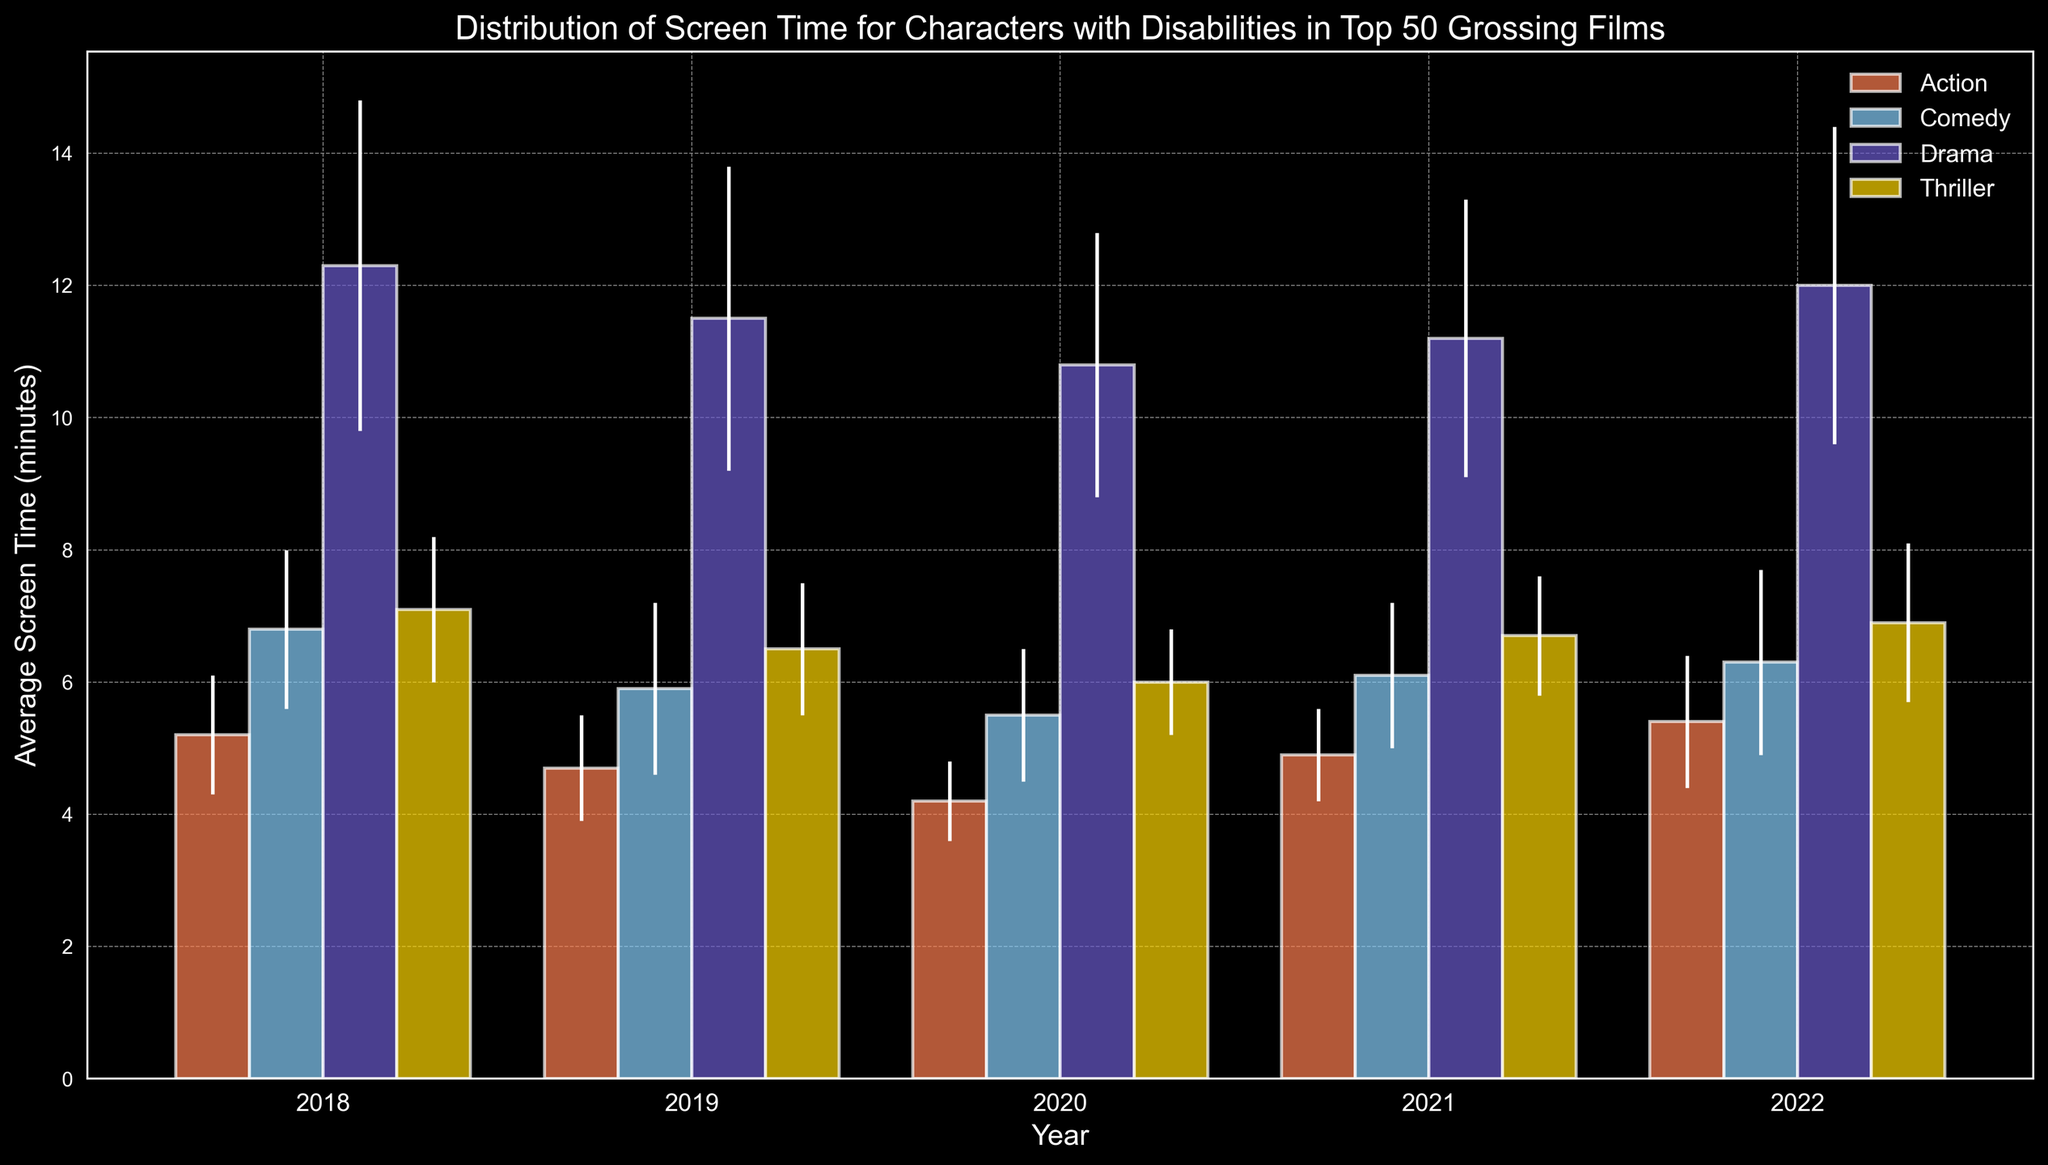What year had the lowest average screen time for characters with disabilities in Action films? Compare the average screen times for Action films across all the years. The lowest average screen time is in 2020 with 4.2 minutes.
Answer: 2020 Which genre showed the most consistent screen time for characters with disabilities from 2018 to 2022? Consistency can be inferred from the smallest standard deviations across the years. Thriller genre consistently has lower standard deviations compared to other genres.
Answer: Thriller Which year saw the highest average screen time for characters with disabilities in Drama films? Compare the average screen times for Drama films across all the years. The highest is in 2018 with 12.3 minutes.
Answer: 2018 Between 2018 and 2022, which genre saw the greatest increase in average screen time for characters with disabilities? Calculate the difference in average screen time for each genre from 2018 to 2022. Drama saw the smallest decrease from 12.3 to 12.0 minutes, while Action saw an increase from 5.2 to 5.4 minutes.
Answer: Action What is the combined average screen time for characters with disabilities in Comedy and Drama films in 2020? Sum the average screen times for Comedy and Drama films in 2020: 5.5 (Comedy) + 10.8 (Drama) = 16.3 minutes.
Answer: 16.3 minutes In which year did Thriller films have nearly the same average screen time as Action films? Compare the average screen times for Thriller and Action films across all the years to find the ones that are close. In 2021, Thriller had 6.7 minutes, and Action had 4.9 minutes.
Answer: 2021 Are the average screen times for characters with disabilities in Comedy films higher or lower than those in Action films across all years? Compare the average screen times for Comedy and Action films for each year. Comedy films consistently have higher average screen times compared to Action films.
Answer: Higher Which year had the smallest difference between the highest and lowest average screen time for characters with disabilities across all genres? Calculate the difference between the highest and lowest average screen time for each year. In 2021, the difference is smallest: Drama (11.2) - Action (4.9) = 6.3 minutes.
Answer: 2021 What color represents Drama films in the chart? Identify the color associated with the bars labeled as Drama in the chart.
Answer: Yellow In 2022, by how much did the average screen time for characters with disabilities in Action films exceed that in 2020? Subtract the average screen time in 2020 from that in 2022: 5.4 (2022) - 4.2 (2020) = 1.2 minutes.
Answer: 1.2 minutes 